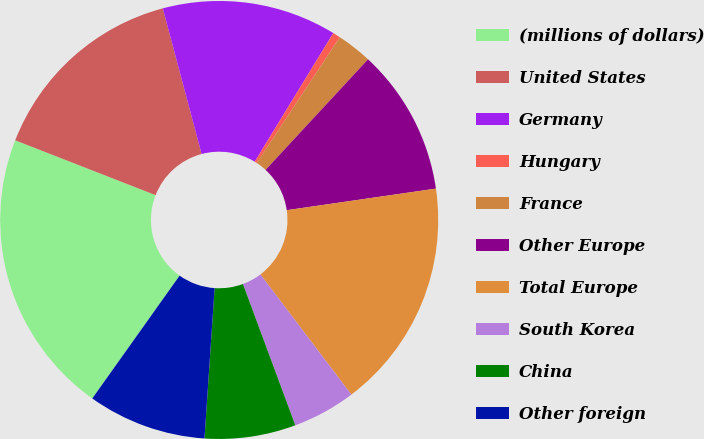<chart> <loc_0><loc_0><loc_500><loc_500><pie_chart><fcel>(millions of dollars)<fcel>United States<fcel>Germany<fcel>Hungary<fcel>France<fcel>Other Europe<fcel>Total Europe<fcel>South Korea<fcel>China<fcel>Other foreign<nl><fcel>21.09%<fcel>14.93%<fcel>12.87%<fcel>0.56%<fcel>2.61%<fcel>10.82%<fcel>16.98%<fcel>4.66%<fcel>6.72%<fcel>8.77%<nl></chart> 